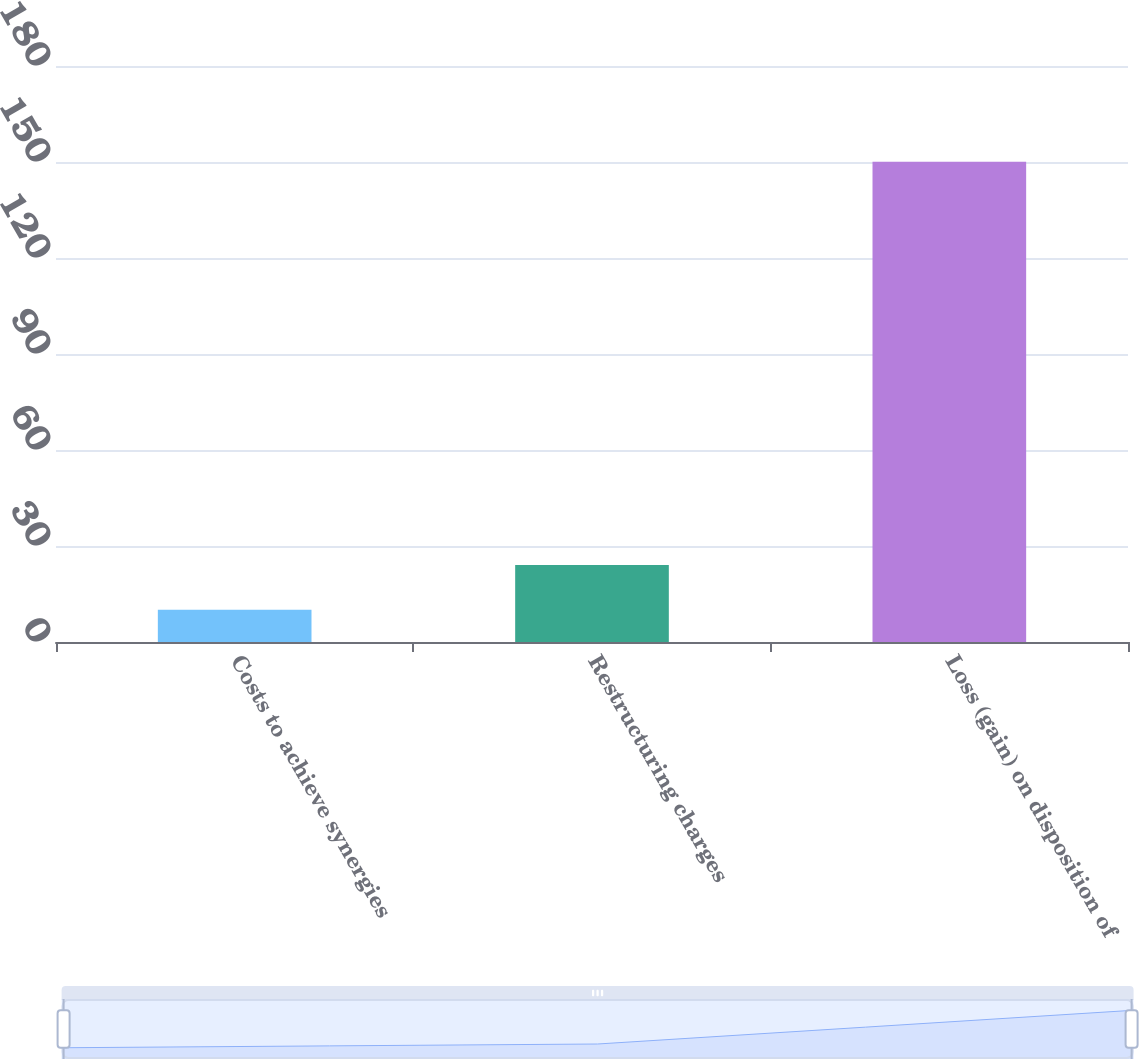Convert chart to OTSL. <chart><loc_0><loc_0><loc_500><loc_500><bar_chart><fcel>Costs to achieve synergies<fcel>Restructuring charges<fcel>Loss (gain) on disposition of<nl><fcel>10.1<fcel>24.1<fcel>150.1<nl></chart> 